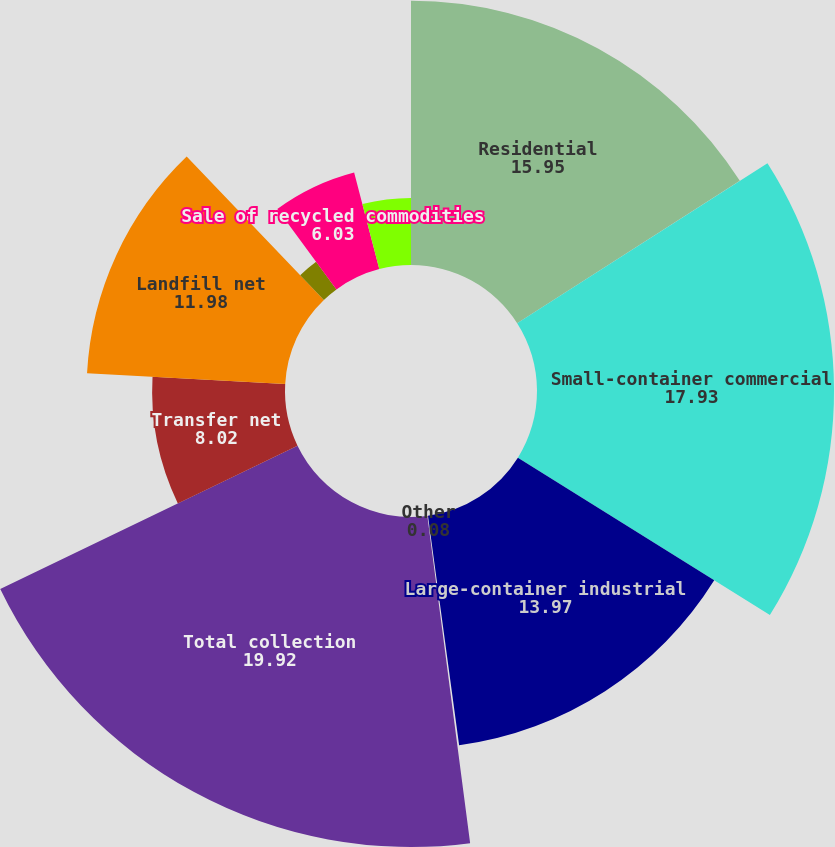Convert chart. <chart><loc_0><loc_0><loc_500><loc_500><pie_chart><fcel>Residential<fcel>Small-container commercial<fcel>Large-container industrial<fcel>Other<fcel>Total collection<fcel>Transfer net<fcel>Landfill net<fcel>Energy services<fcel>Sale of recycled commodities<fcel>Other non-core<nl><fcel>15.95%<fcel>17.93%<fcel>13.97%<fcel>0.08%<fcel>19.92%<fcel>8.02%<fcel>11.98%<fcel>2.07%<fcel>6.03%<fcel>4.05%<nl></chart> 